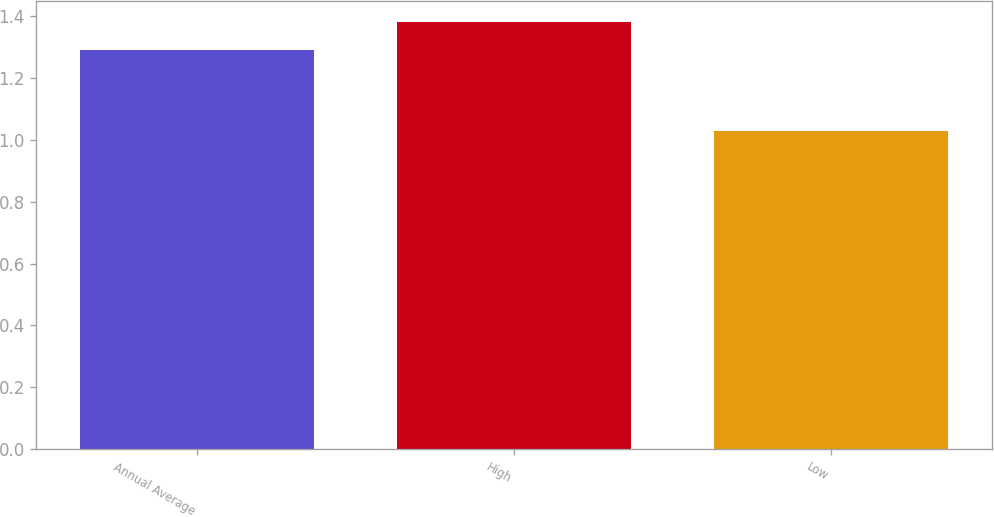<chart> <loc_0><loc_0><loc_500><loc_500><bar_chart><fcel>Annual Average<fcel>High<fcel>Low<nl><fcel>1.29<fcel>1.38<fcel>1.03<nl></chart> 